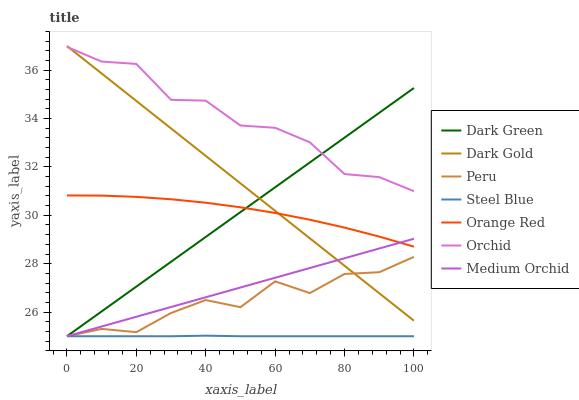Does Medium Orchid have the minimum area under the curve?
Answer yes or no. No. Does Medium Orchid have the maximum area under the curve?
Answer yes or no. No. Is Steel Blue the smoothest?
Answer yes or no. No. Is Steel Blue the roughest?
Answer yes or no. No. Does Orange Red have the lowest value?
Answer yes or no. No. Does Medium Orchid have the highest value?
Answer yes or no. No. Is Peru less than Orange Red?
Answer yes or no. Yes. Is Orchid greater than Steel Blue?
Answer yes or no. Yes. Does Peru intersect Orange Red?
Answer yes or no. No. 